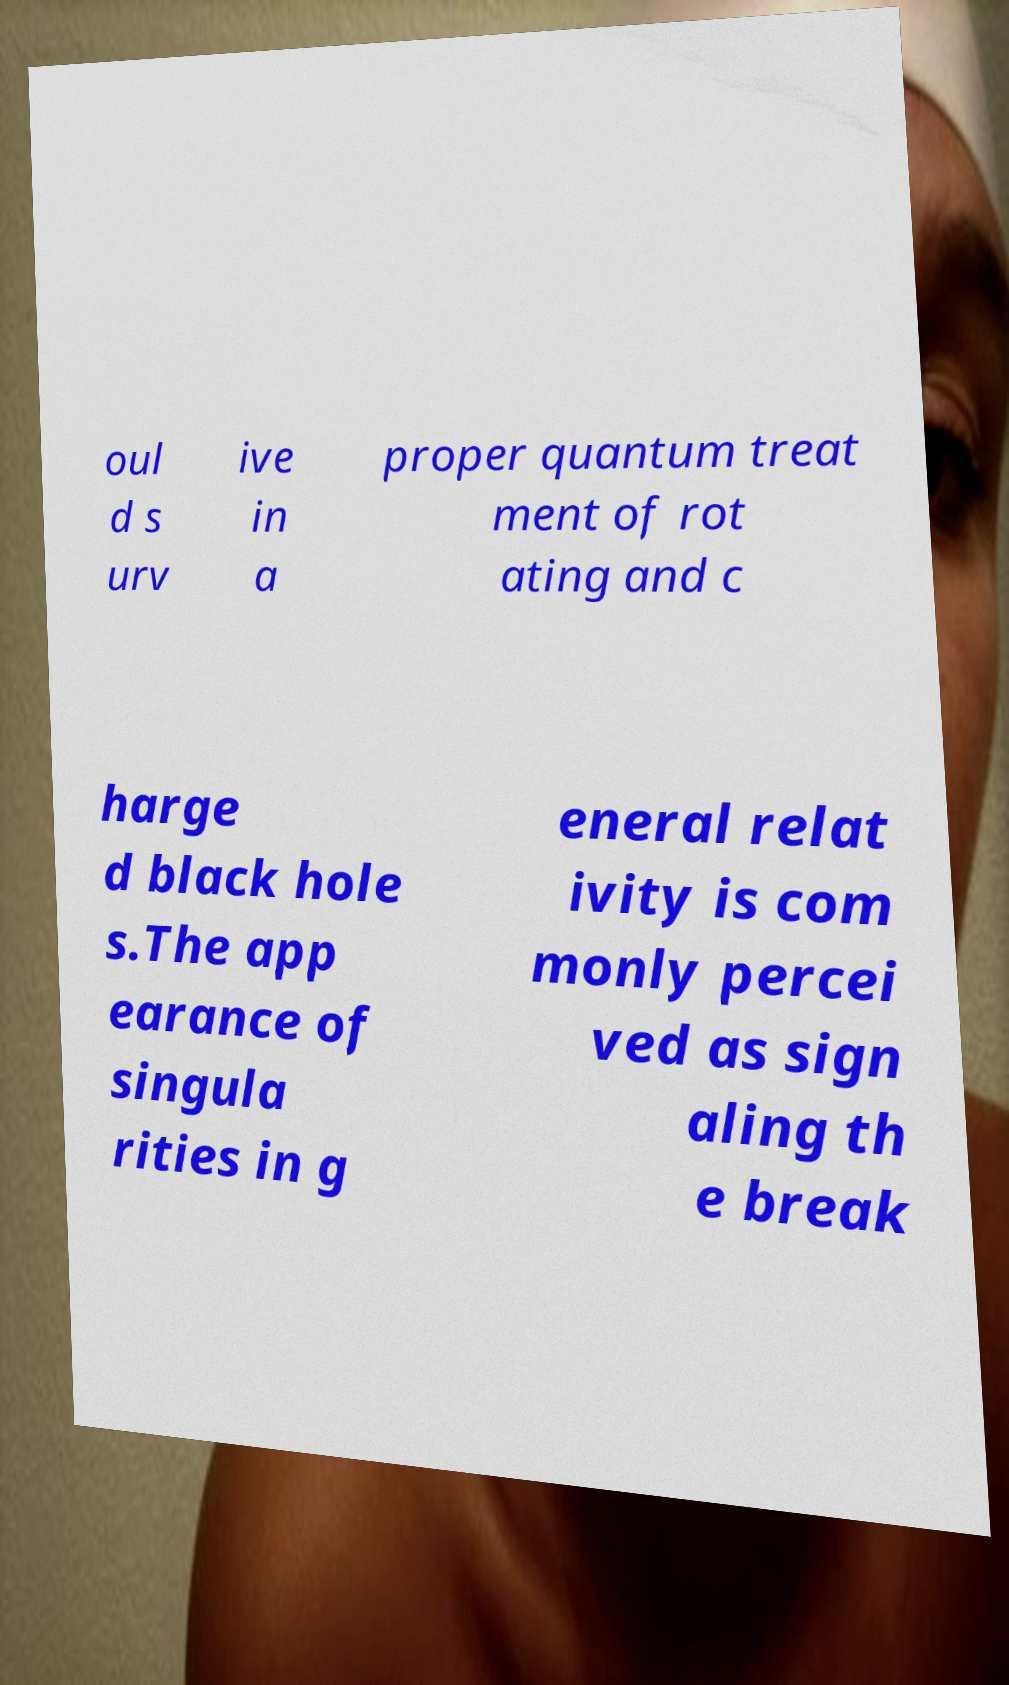I need the written content from this picture converted into text. Can you do that? oul d s urv ive in a proper quantum treat ment of rot ating and c harge d black hole s.The app earance of singula rities in g eneral relat ivity is com monly percei ved as sign aling th e break 